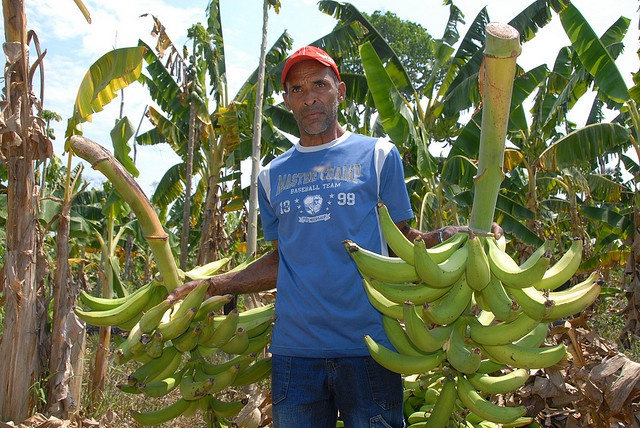Describe the objects in this image and their specific colors. I can see people in white, blue, black, darkblue, and navy tones, banana in white, olive, and khaki tones, and banana in white, darkgreen, olive, and gray tones in this image. 